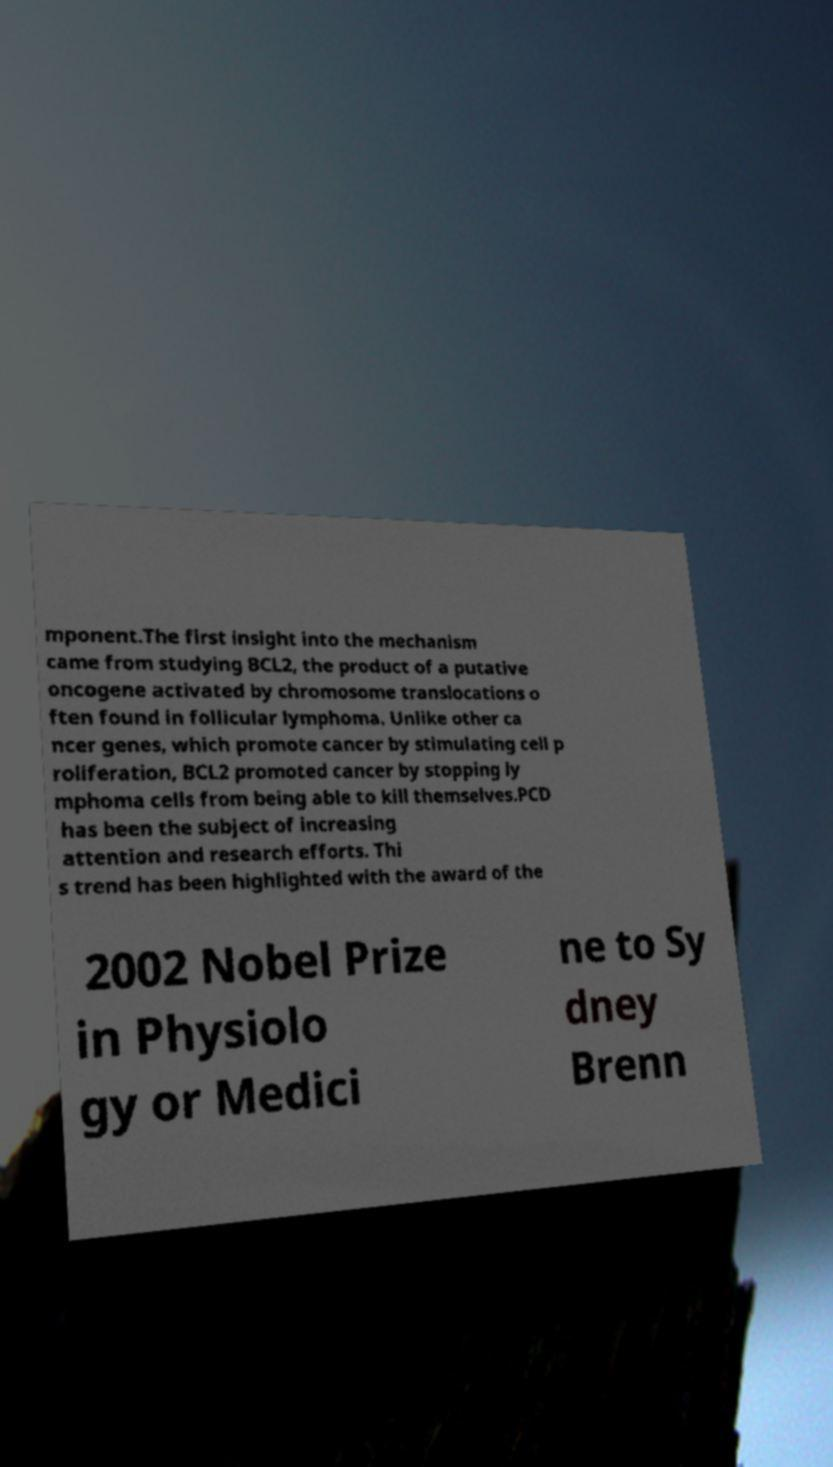Could you assist in decoding the text presented in this image and type it out clearly? mponent.The first insight into the mechanism came from studying BCL2, the product of a putative oncogene activated by chromosome translocations o ften found in follicular lymphoma. Unlike other ca ncer genes, which promote cancer by stimulating cell p roliferation, BCL2 promoted cancer by stopping ly mphoma cells from being able to kill themselves.PCD has been the subject of increasing attention and research efforts. Thi s trend has been highlighted with the award of the 2002 Nobel Prize in Physiolo gy or Medici ne to Sy dney Brenn 